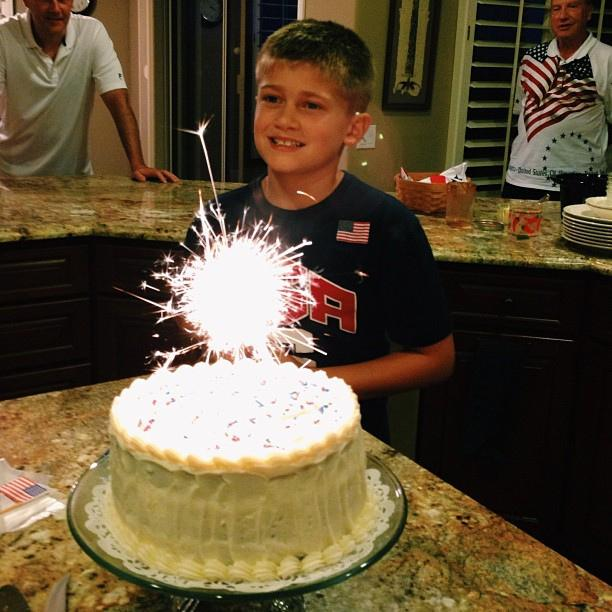What holiday is this cake likeliest to commemorate?

Choices:
A) wedding
B) birthday
C) 4th july
D) anniversary 4th july 